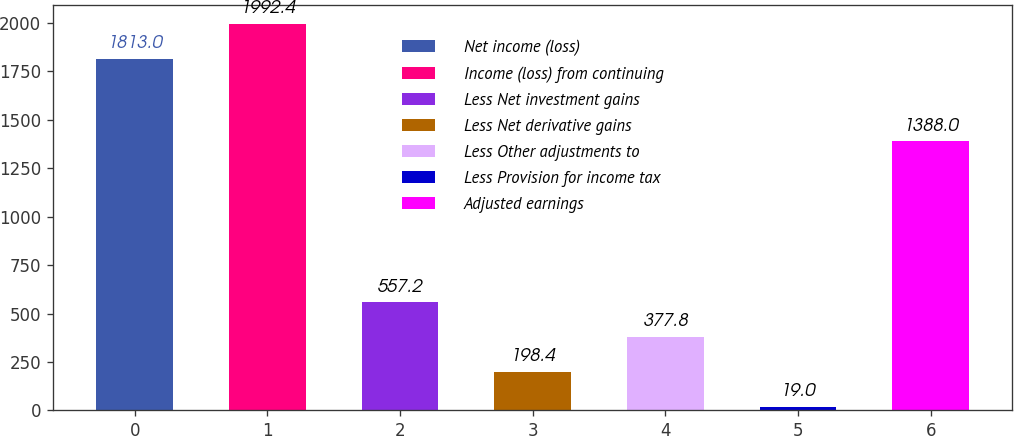<chart> <loc_0><loc_0><loc_500><loc_500><bar_chart><fcel>Net income (loss)<fcel>Income (loss) from continuing<fcel>Less Net investment gains<fcel>Less Net derivative gains<fcel>Less Other adjustments to<fcel>Less Provision for income tax<fcel>Adjusted earnings<nl><fcel>1813<fcel>1992.4<fcel>557.2<fcel>198.4<fcel>377.8<fcel>19<fcel>1388<nl></chart> 